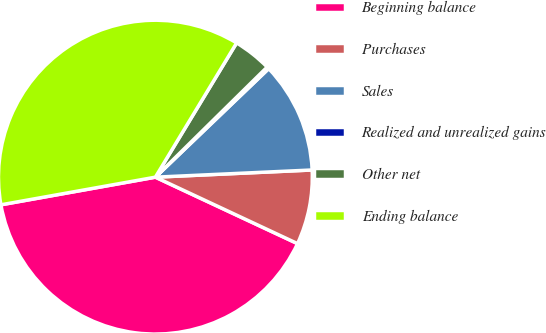Convert chart. <chart><loc_0><loc_0><loc_500><loc_500><pie_chart><fcel>Beginning balance<fcel>Purchases<fcel>Sales<fcel>Realized and unrealized gains<fcel>Other net<fcel>Ending balance<nl><fcel>40.22%<fcel>7.69%<fcel>11.43%<fcel>0.22%<fcel>3.96%<fcel>36.48%<nl></chart> 